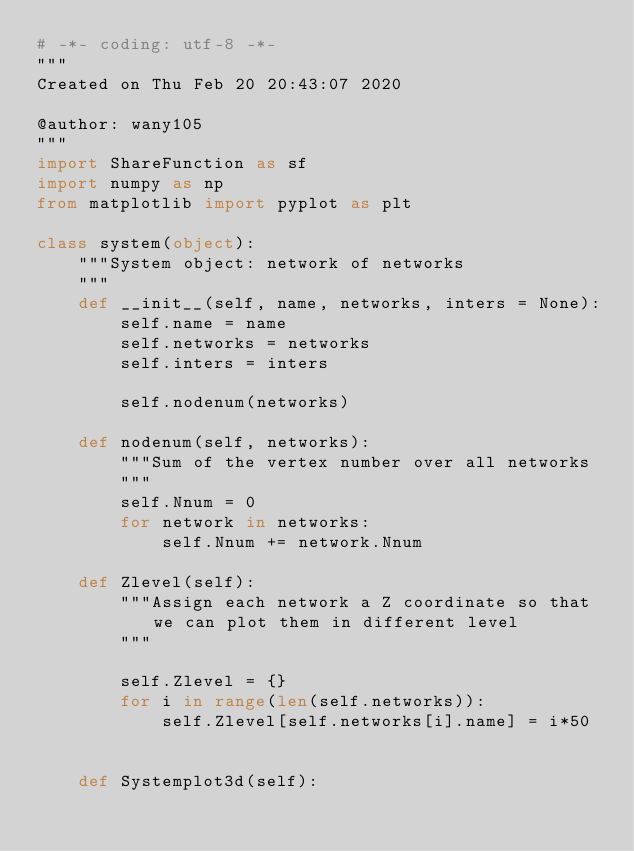<code> <loc_0><loc_0><loc_500><loc_500><_Python_># -*- coding: utf-8 -*-
"""
Created on Thu Feb 20 20:43:07 2020

@author: wany105
"""
import ShareFunction as sf
import numpy as np
from matplotlib import pyplot as plt

class system(object):
    """System object: network of networks
    """
    def __init__(self, name, networks, inters = None):
        self.name = name
        self.networks = networks
        self.inters = inters
        
        self.nodenum(networks)
        
    def nodenum(self, networks):
        """Sum of the vertex number over all networks
        """
        self.Nnum = 0
        for network in networks:
            self.Nnum += network.Nnum
        
    def Zlevel(self):
        """Assign each network a Z coordinate so that we can plot them in different level
        """
        
        self.Zlevel = {}
        for i in range(len(self.networks)):
            self.Zlevel[self.networks[i].name] = i*50        
            
        
    def Systemplot3d(self):</code> 